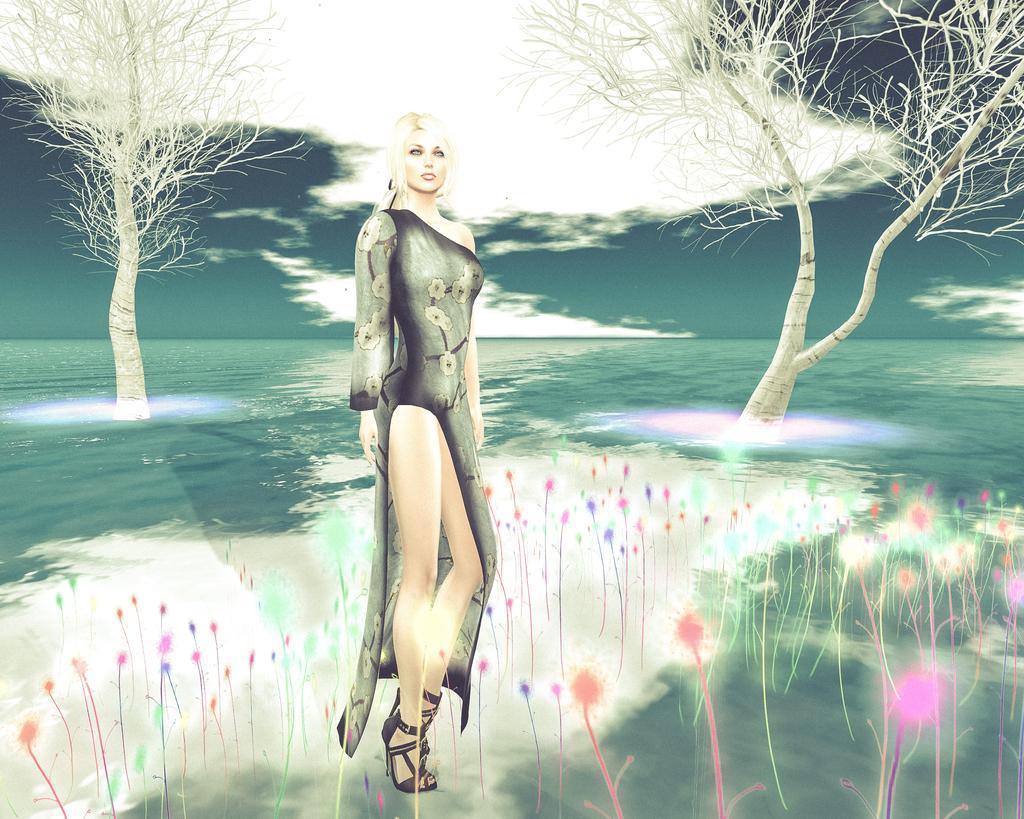Can you describe this image briefly? As we can see in the image there is painting of a woman wearing black color dress, water, trees, sky and clouds. 